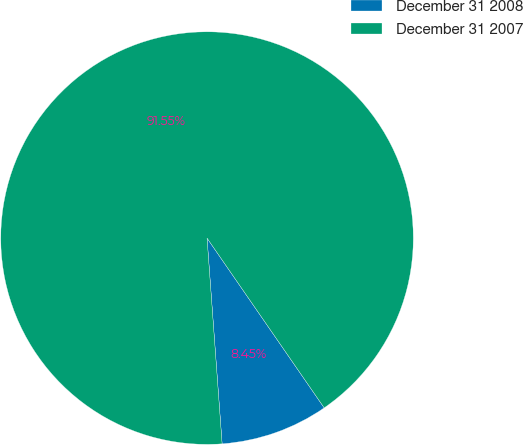<chart> <loc_0><loc_0><loc_500><loc_500><pie_chart><fcel>December 31 2008<fcel>December 31 2007<nl><fcel>8.45%<fcel>91.55%<nl></chart> 